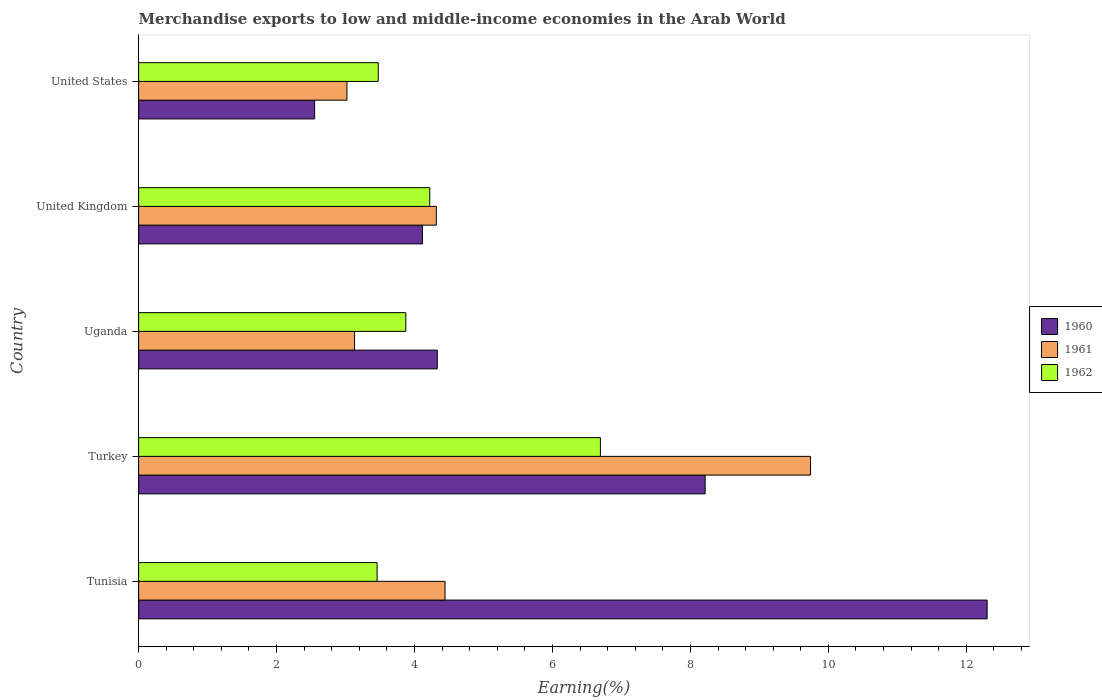How many bars are there on the 2nd tick from the top?
Offer a very short reply. 3. What is the label of the 4th group of bars from the top?
Keep it short and to the point. Turkey. In how many cases, is the number of bars for a given country not equal to the number of legend labels?
Provide a succinct answer. 0. What is the percentage of amount earned from merchandise exports in 1960 in United Kingdom?
Give a very brief answer. 4.11. Across all countries, what is the maximum percentage of amount earned from merchandise exports in 1962?
Your answer should be very brief. 6.69. Across all countries, what is the minimum percentage of amount earned from merchandise exports in 1962?
Provide a short and direct response. 3.46. In which country was the percentage of amount earned from merchandise exports in 1961 maximum?
Provide a succinct answer. Turkey. In which country was the percentage of amount earned from merchandise exports in 1962 minimum?
Your answer should be compact. Tunisia. What is the total percentage of amount earned from merchandise exports in 1961 in the graph?
Your response must be concise. 24.65. What is the difference between the percentage of amount earned from merchandise exports in 1962 in Turkey and that in United States?
Give a very brief answer. 3.22. What is the difference between the percentage of amount earned from merchandise exports in 1961 in Uganda and the percentage of amount earned from merchandise exports in 1960 in Tunisia?
Your response must be concise. -9.17. What is the average percentage of amount earned from merchandise exports in 1960 per country?
Your response must be concise. 6.3. What is the difference between the percentage of amount earned from merchandise exports in 1962 and percentage of amount earned from merchandise exports in 1960 in Tunisia?
Give a very brief answer. -8.84. What is the ratio of the percentage of amount earned from merchandise exports in 1961 in Tunisia to that in Uganda?
Your answer should be compact. 1.42. Is the percentage of amount earned from merchandise exports in 1961 in Tunisia less than that in Uganda?
Provide a short and direct response. No. What is the difference between the highest and the second highest percentage of amount earned from merchandise exports in 1961?
Offer a very short reply. 5.3. What is the difference between the highest and the lowest percentage of amount earned from merchandise exports in 1960?
Provide a short and direct response. 9.75. In how many countries, is the percentage of amount earned from merchandise exports in 1960 greater than the average percentage of amount earned from merchandise exports in 1960 taken over all countries?
Your answer should be very brief. 2. What does the 3rd bar from the top in United States represents?
Make the answer very short. 1960. What does the 1st bar from the bottom in Turkey represents?
Your answer should be very brief. 1960. Is it the case that in every country, the sum of the percentage of amount earned from merchandise exports in 1961 and percentage of amount earned from merchandise exports in 1960 is greater than the percentage of amount earned from merchandise exports in 1962?
Give a very brief answer. Yes. Are all the bars in the graph horizontal?
Keep it short and to the point. Yes. How many countries are there in the graph?
Your answer should be compact. 5. What is the difference between two consecutive major ticks on the X-axis?
Give a very brief answer. 2. Does the graph contain any zero values?
Offer a very short reply. No. Where does the legend appear in the graph?
Ensure brevity in your answer.  Center right. What is the title of the graph?
Offer a very short reply. Merchandise exports to low and middle-income economies in the Arab World. What is the label or title of the X-axis?
Make the answer very short. Earning(%). What is the Earning(%) in 1960 in Tunisia?
Keep it short and to the point. 12.3. What is the Earning(%) in 1961 in Tunisia?
Your answer should be very brief. 4.44. What is the Earning(%) in 1962 in Tunisia?
Offer a very short reply. 3.46. What is the Earning(%) in 1960 in Turkey?
Your answer should be compact. 8.21. What is the Earning(%) of 1961 in Turkey?
Offer a very short reply. 9.74. What is the Earning(%) in 1962 in Turkey?
Offer a very short reply. 6.69. What is the Earning(%) in 1960 in Uganda?
Offer a terse response. 4.33. What is the Earning(%) in 1961 in Uganda?
Ensure brevity in your answer.  3.13. What is the Earning(%) in 1962 in Uganda?
Offer a very short reply. 3.87. What is the Earning(%) in 1960 in United Kingdom?
Keep it short and to the point. 4.11. What is the Earning(%) of 1961 in United Kingdom?
Keep it short and to the point. 4.32. What is the Earning(%) in 1962 in United Kingdom?
Ensure brevity in your answer.  4.22. What is the Earning(%) of 1960 in United States?
Provide a short and direct response. 2.55. What is the Earning(%) in 1961 in United States?
Offer a very short reply. 3.02. What is the Earning(%) of 1962 in United States?
Keep it short and to the point. 3.47. Across all countries, what is the maximum Earning(%) of 1960?
Offer a very short reply. 12.3. Across all countries, what is the maximum Earning(%) of 1961?
Keep it short and to the point. 9.74. Across all countries, what is the maximum Earning(%) in 1962?
Give a very brief answer. 6.69. Across all countries, what is the minimum Earning(%) of 1960?
Provide a short and direct response. 2.55. Across all countries, what is the minimum Earning(%) of 1961?
Offer a very short reply. 3.02. Across all countries, what is the minimum Earning(%) in 1962?
Give a very brief answer. 3.46. What is the total Earning(%) of 1960 in the graph?
Give a very brief answer. 31.51. What is the total Earning(%) in 1961 in the graph?
Offer a terse response. 24.65. What is the total Earning(%) of 1962 in the graph?
Make the answer very short. 21.72. What is the difference between the Earning(%) of 1960 in Tunisia and that in Turkey?
Provide a short and direct response. 4.09. What is the difference between the Earning(%) of 1961 in Tunisia and that in Turkey?
Make the answer very short. -5.3. What is the difference between the Earning(%) of 1962 in Tunisia and that in Turkey?
Make the answer very short. -3.24. What is the difference between the Earning(%) in 1960 in Tunisia and that in Uganda?
Keep it short and to the point. 7.97. What is the difference between the Earning(%) in 1961 in Tunisia and that in Uganda?
Offer a terse response. 1.31. What is the difference between the Earning(%) in 1962 in Tunisia and that in Uganda?
Provide a short and direct response. -0.42. What is the difference between the Earning(%) of 1960 in Tunisia and that in United Kingdom?
Offer a terse response. 8.19. What is the difference between the Earning(%) of 1961 in Tunisia and that in United Kingdom?
Your response must be concise. 0.13. What is the difference between the Earning(%) in 1962 in Tunisia and that in United Kingdom?
Give a very brief answer. -0.76. What is the difference between the Earning(%) of 1960 in Tunisia and that in United States?
Your answer should be very brief. 9.75. What is the difference between the Earning(%) of 1961 in Tunisia and that in United States?
Keep it short and to the point. 1.42. What is the difference between the Earning(%) of 1962 in Tunisia and that in United States?
Provide a succinct answer. -0.02. What is the difference between the Earning(%) of 1960 in Turkey and that in Uganda?
Make the answer very short. 3.88. What is the difference between the Earning(%) of 1961 in Turkey and that in Uganda?
Keep it short and to the point. 6.61. What is the difference between the Earning(%) in 1962 in Turkey and that in Uganda?
Make the answer very short. 2.82. What is the difference between the Earning(%) of 1960 in Turkey and that in United Kingdom?
Your answer should be very brief. 4.1. What is the difference between the Earning(%) of 1961 in Turkey and that in United Kingdom?
Make the answer very short. 5.42. What is the difference between the Earning(%) of 1962 in Turkey and that in United Kingdom?
Ensure brevity in your answer.  2.47. What is the difference between the Earning(%) of 1960 in Turkey and that in United States?
Offer a very short reply. 5.66. What is the difference between the Earning(%) of 1961 in Turkey and that in United States?
Provide a short and direct response. 6.72. What is the difference between the Earning(%) of 1962 in Turkey and that in United States?
Provide a short and direct response. 3.22. What is the difference between the Earning(%) in 1960 in Uganda and that in United Kingdom?
Offer a terse response. 0.21. What is the difference between the Earning(%) of 1961 in Uganda and that in United Kingdom?
Your answer should be compact. -1.19. What is the difference between the Earning(%) of 1962 in Uganda and that in United Kingdom?
Provide a short and direct response. -0.35. What is the difference between the Earning(%) of 1960 in Uganda and that in United States?
Make the answer very short. 1.78. What is the difference between the Earning(%) in 1961 in Uganda and that in United States?
Give a very brief answer. 0.11. What is the difference between the Earning(%) in 1962 in Uganda and that in United States?
Offer a very short reply. 0.4. What is the difference between the Earning(%) of 1960 in United Kingdom and that in United States?
Your answer should be very brief. 1.56. What is the difference between the Earning(%) in 1961 in United Kingdom and that in United States?
Offer a terse response. 1.3. What is the difference between the Earning(%) in 1962 in United Kingdom and that in United States?
Your response must be concise. 0.75. What is the difference between the Earning(%) of 1960 in Tunisia and the Earning(%) of 1961 in Turkey?
Offer a very short reply. 2.56. What is the difference between the Earning(%) in 1960 in Tunisia and the Earning(%) in 1962 in Turkey?
Offer a terse response. 5.61. What is the difference between the Earning(%) of 1961 in Tunisia and the Earning(%) of 1962 in Turkey?
Offer a terse response. -2.25. What is the difference between the Earning(%) in 1960 in Tunisia and the Earning(%) in 1961 in Uganda?
Ensure brevity in your answer.  9.17. What is the difference between the Earning(%) in 1960 in Tunisia and the Earning(%) in 1962 in Uganda?
Your answer should be compact. 8.43. What is the difference between the Earning(%) in 1961 in Tunisia and the Earning(%) in 1962 in Uganda?
Ensure brevity in your answer.  0.57. What is the difference between the Earning(%) of 1960 in Tunisia and the Earning(%) of 1961 in United Kingdom?
Give a very brief answer. 7.99. What is the difference between the Earning(%) in 1960 in Tunisia and the Earning(%) in 1962 in United Kingdom?
Keep it short and to the point. 8.08. What is the difference between the Earning(%) of 1961 in Tunisia and the Earning(%) of 1962 in United Kingdom?
Your response must be concise. 0.22. What is the difference between the Earning(%) in 1960 in Tunisia and the Earning(%) in 1961 in United States?
Provide a succinct answer. 9.28. What is the difference between the Earning(%) in 1960 in Tunisia and the Earning(%) in 1962 in United States?
Ensure brevity in your answer.  8.83. What is the difference between the Earning(%) in 1961 in Tunisia and the Earning(%) in 1962 in United States?
Your answer should be compact. 0.97. What is the difference between the Earning(%) of 1960 in Turkey and the Earning(%) of 1961 in Uganda?
Provide a short and direct response. 5.08. What is the difference between the Earning(%) in 1960 in Turkey and the Earning(%) in 1962 in Uganda?
Offer a terse response. 4.34. What is the difference between the Earning(%) in 1961 in Turkey and the Earning(%) in 1962 in Uganda?
Ensure brevity in your answer.  5.87. What is the difference between the Earning(%) of 1960 in Turkey and the Earning(%) of 1961 in United Kingdom?
Give a very brief answer. 3.9. What is the difference between the Earning(%) of 1960 in Turkey and the Earning(%) of 1962 in United Kingdom?
Make the answer very short. 3.99. What is the difference between the Earning(%) of 1961 in Turkey and the Earning(%) of 1962 in United Kingdom?
Ensure brevity in your answer.  5.52. What is the difference between the Earning(%) of 1960 in Turkey and the Earning(%) of 1961 in United States?
Your response must be concise. 5.19. What is the difference between the Earning(%) of 1960 in Turkey and the Earning(%) of 1962 in United States?
Give a very brief answer. 4.74. What is the difference between the Earning(%) of 1961 in Turkey and the Earning(%) of 1962 in United States?
Provide a short and direct response. 6.27. What is the difference between the Earning(%) of 1960 in Uganda and the Earning(%) of 1961 in United Kingdom?
Offer a terse response. 0.01. What is the difference between the Earning(%) of 1960 in Uganda and the Earning(%) of 1962 in United Kingdom?
Your response must be concise. 0.11. What is the difference between the Earning(%) of 1961 in Uganda and the Earning(%) of 1962 in United Kingdom?
Ensure brevity in your answer.  -1.09. What is the difference between the Earning(%) of 1960 in Uganda and the Earning(%) of 1961 in United States?
Offer a very short reply. 1.31. What is the difference between the Earning(%) of 1960 in Uganda and the Earning(%) of 1962 in United States?
Offer a very short reply. 0.86. What is the difference between the Earning(%) of 1961 in Uganda and the Earning(%) of 1962 in United States?
Your answer should be compact. -0.34. What is the difference between the Earning(%) of 1960 in United Kingdom and the Earning(%) of 1961 in United States?
Make the answer very short. 1.09. What is the difference between the Earning(%) in 1960 in United Kingdom and the Earning(%) in 1962 in United States?
Provide a succinct answer. 0.64. What is the difference between the Earning(%) of 1961 in United Kingdom and the Earning(%) of 1962 in United States?
Provide a short and direct response. 0.84. What is the average Earning(%) of 1960 per country?
Ensure brevity in your answer.  6.3. What is the average Earning(%) in 1961 per country?
Provide a succinct answer. 4.93. What is the average Earning(%) in 1962 per country?
Keep it short and to the point. 4.34. What is the difference between the Earning(%) of 1960 and Earning(%) of 1961 in Tunisia?
Make the answer very short. 7.86. What is the difference between the Earning(%) in 1960 and Earning(%) in 1962 in Tunisia?
Provide a short and direct response. 8.84. What is the difference between the Earning(%) of 1961 and Earning(%) of 1962 in Tunisia?
Provide a short and direct response. 0.99. What is the difference between the Earning(%) in 1960 and Earning(%) in 1961 in Turkey?
Provide a short and direct response. -1.53. What is the difference between the Earning(%) in 1960 and Earning(%) in 1962 in Turkey?
Your answer should be very brief. 1.52. What is the difference between the Earning(%) in 1961 and Earning(%) in 1962 in Turkey?
Your answer should be compact. 3.05. What is the difference between the Earning(%) of 1960 and Earning(%) of 1961 in Uganda?
Give a very brief answer. 1.2. What is the difference between the Earning(%) of 1960 and Earning(%) of 1962 in Uganda?
Your answer should be very brief. 0.46. What is the difference between the Earning(%) of 1961 and Earning(%) of 1962 in Uganda?
Keep it short and to the point. -0.74. What is the difference between the Earning(%) of 1960 and Earning(%) of 1961 in United Kingdom?
Give a very brief answer. -0.2. What is the difference between the Earning(%) in 1960 and Earning(%) in 1962 in United Kingdom?
Ensure brevity in your answer.  -0.11. What is the difference between the Earning(%) of 1961 and Earning(%) of 1962 in United Kingdom?
Offer a terse response. 0.1. What is the difference between the Earning(%) in 1960 and Earning(%) in 1961 in United States?
Provide a succinct answer. -0.47. What is the difference between the Earning(%) of 1960 and Earning(%) of 1962 in United States?
Provide a short and direct response. -0.92. What is the difference between the Earning(%) of 1961 and Earning(%) of 1962 in United States?
Your answer should be compact. -0.45. What is the ratio of the Earning(%) in 1960 in Tunisia to that in Turkey?
Provide a short and direct response. 1.5. What is the ratio of the Earning(%) in 1961 in Tunisia to that in Turkey?
Your answer should be compact. 0.46. What is the ratio of the Earning(%) in 1962 in Tunisia to that in Turkey?
Keep it short and to the point. 0.52. What is the ratio of the Earning(%) in 1960 in Tunisia to that in Uganda?
Make the answer very short. 2.84. What is the ratio of the Earning(%) of 1961 in Tunisia to that in Uganda?
Keep it short and to the point. 1.42. What is the ratio of the Earning(%) of 1962 in Tunisia to that in Uganda?
Your response must be concise. 0.89. What is the ratio of the Earning(%) in 1960 in Tunisia to that in United Kingdom?
Ensure brevity in your answer.  2.99. What is the ratio of the Earning(%) of 1961 in Tunisia to that in United Kingdom?
Give a very brief answer. 1.03. What is the ratio of the Earning(%) of 1962 in Tunisia to that in United Kingdom?
Make the answer very short. 0.82. What is the ratio of the Earning(%) of 1960 in Tunisia to that in United States?
Make the answer very short. 4.82. What is the ratio of the Earning(%) in 1961 in Tunisia to that in United States?
Offer a terse response. 1.47. What is the ratio of the Earning(%) in 1960 in Turkey to that in Uganda?
Give a very brief answer. 1.9. What is the ratio of the Earning(%) in 1961 in Turkey to that in Uganda?
Offer a very short reply. 3.11. What is the ratio of the Earning(%) of 1962 in Turkey to that in Uganda?
Give a very brief answer. 1.73. What is the ratio of the Earning(%) in 1960 in Turkey to that in United Kingdom?
Keep it short and to the point. 2. What is the ratio of the Earning(%) in 1961 in Turkey to that in United Kingdom?
Offer a terse response. 2.26. What is the ratio of the Earning(%) of 1962 in Turkey to that in United Kingdom?
Make the answer very short. 1.59. What is the ratio of the Earning(%) in 1960 in Turkey to that in United States?
Your answer should be very brief. 3.22. What is the ratio of the Earning(%) of 1961 in Turkey to that in United States?
Provide a succinct answer. 3.23. What is the ratio of the Earning(%) in 1962 in Turkey to that in United States?
Your answer should be very brief. 1.93. What is the ratio of the Earning(%) of 1960 in Uganda to that in United Kingdom?
Keep it short and to the point. 1.05. What is the ratio of the Earning(%) in 1961 in Uganda to that in United Kingdom?
Keep it short and to the point. 0.73. What is the ratio of the Earning(%) in 1962 in Uganda to that in United Kingdom?
Keep it short and to the point. 0.92. What is the ratio of the Earning(%) of 1960 in Uganda to that in United States?
Your answer should be compact. 1.7. What is the ratio of the Earning(%) in 1961 in Uganda to that in United States?
Ensure brevity in your answer.  1.04. What is the ratio of the Earning(%) in 1962 in Uganda to that in United States?
Keep it short and to the point. 1.11. What is the ratio of the Earning(%) of 1960 in United Kingdom to that in United States?
Your answer should be compact. 1.61. What is the ratio of the Earning(%) of 1961 in United Kingdom to that in United States?
Offer a terse response. 1.43. What is the ratio of the Earning(%) in 1962 in United Kingdom to that in United States?
Make the answer very short. 1.21. What is the difference between the highest and the second highest Earning(%) of 1960?
Give a very brief answer. 4.09. What is the difference between the highest and the second highest Earning(%) in 1961?
Your answer should be very brief. 5.3. What is the difference between the highest and the second highest Earning(%) of 1962?
Keep it short and to the point. 2.47. What is the difference between the highest and the lowest Earning(%) of 1960?
Give a very brief answer. 9.75. What is the difference between the highest and the lowest Earning(%) of 1961?
Make the answer very short. 6.72. What is the difference between the highest and the lowest Earning(%) of 1962?
Keep it short and to the point. 3.24. 